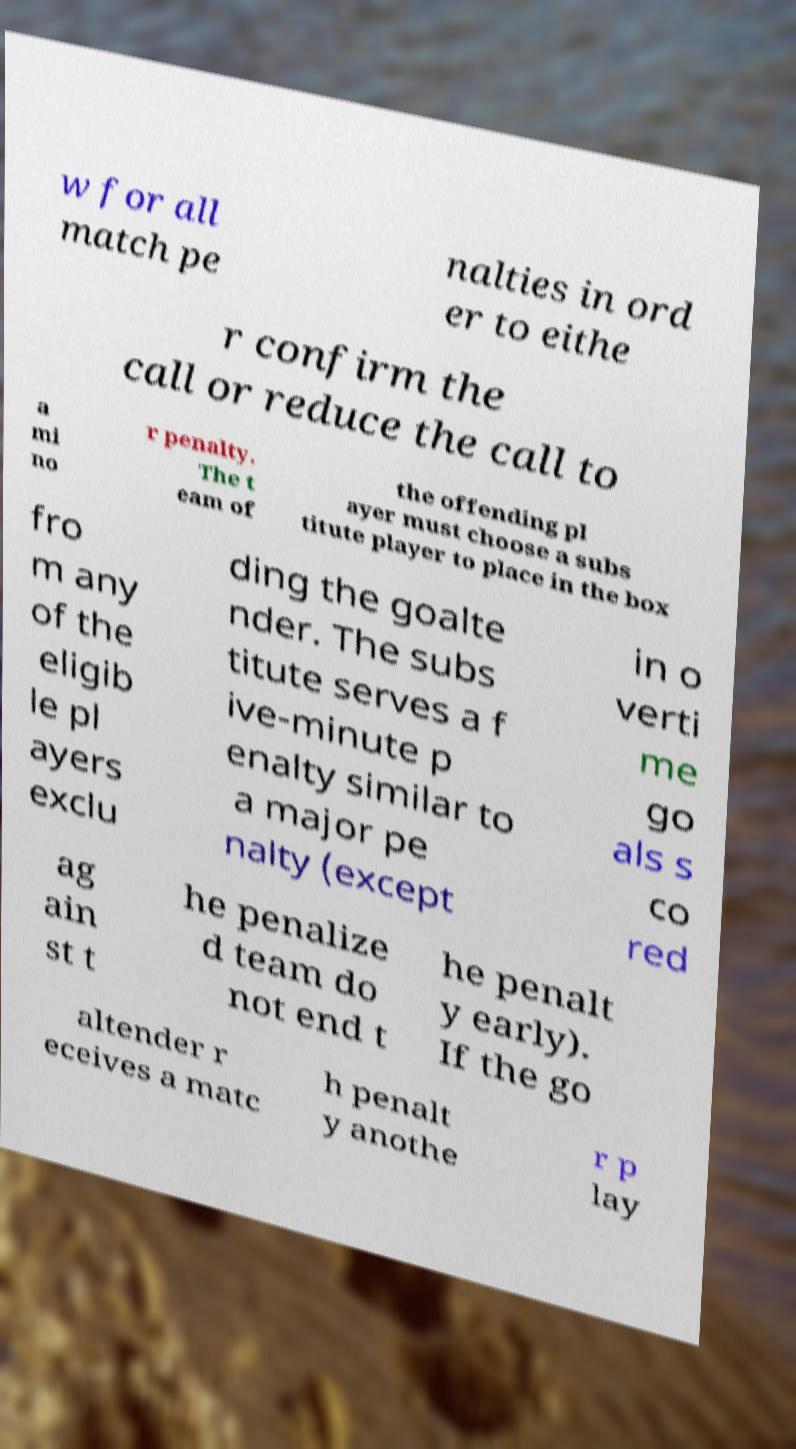Please read and relay the text visible in this image. What does it say? w for all match pe nalties in ord er to eithe r confirm the call or reduce the call to a mi no r penalty. The t eam of the offending pl ayer must choose a subs titute player to place in the box fro m any of the eligib le pl ayers exclu ding the goalte nder. The subs titute serves a f ive-minute p enalty similar to a major pe nalty (except in o verti me go als s co red ag ain st t he penalize d team do not end t he penalt y early). If the go altender r eceives a matc h penalt y anothe r p lay 